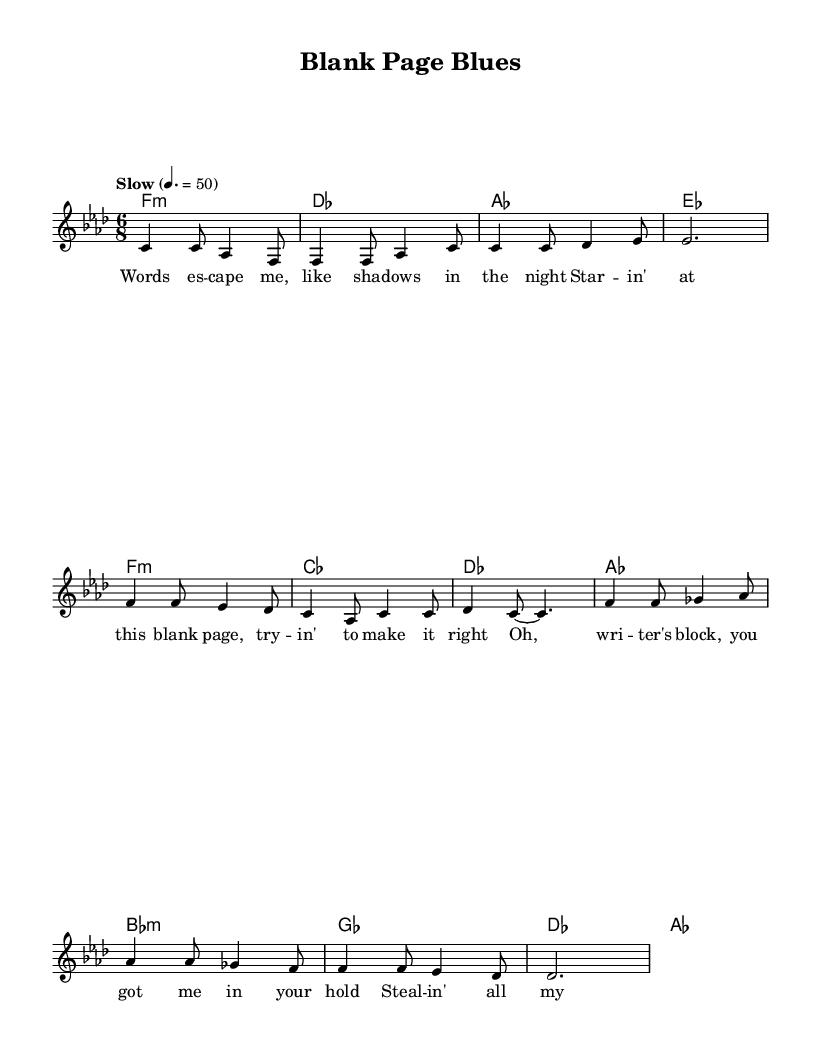What is the key signature of this music? The key signature is indicated by the number of flats or sharps at the beginning of the staff. In this case, there is a B flat and E flat which represent the F minor key signature.
Answer: F minor What is the time signature of this piece? The time signature is presented as a fraction at the beginning of the score. Here, it shows a 6/8 signature, denoting there are six eighth notes per measure.
Answer: 6/8 What is the tempo marking of the piece? The tempo marking is found near the top of the score, indicating the speed at which the music should be played. In this case, it reads "Slow" with a specific metronome marking of 50.
Answer: Slow How many measures are in the verse section? By counting the number of distinct measures in the melody section labeled as "Verse," we find there are four measures.
Answer: 4 Which section contains the lines "Oh, writer's block, you got me in your hold"? The lyrics are set to the music in specific sections. The quoted line appears in the "Chorus," which is the section following the "Verse".
Answer: Chorus What type of chord is played during the verse? The chord symbols under the staff indicate the harmonies used throughout the music. Here, the verse uses minor chords, specifically an F minor chord.
Answer: F:min 